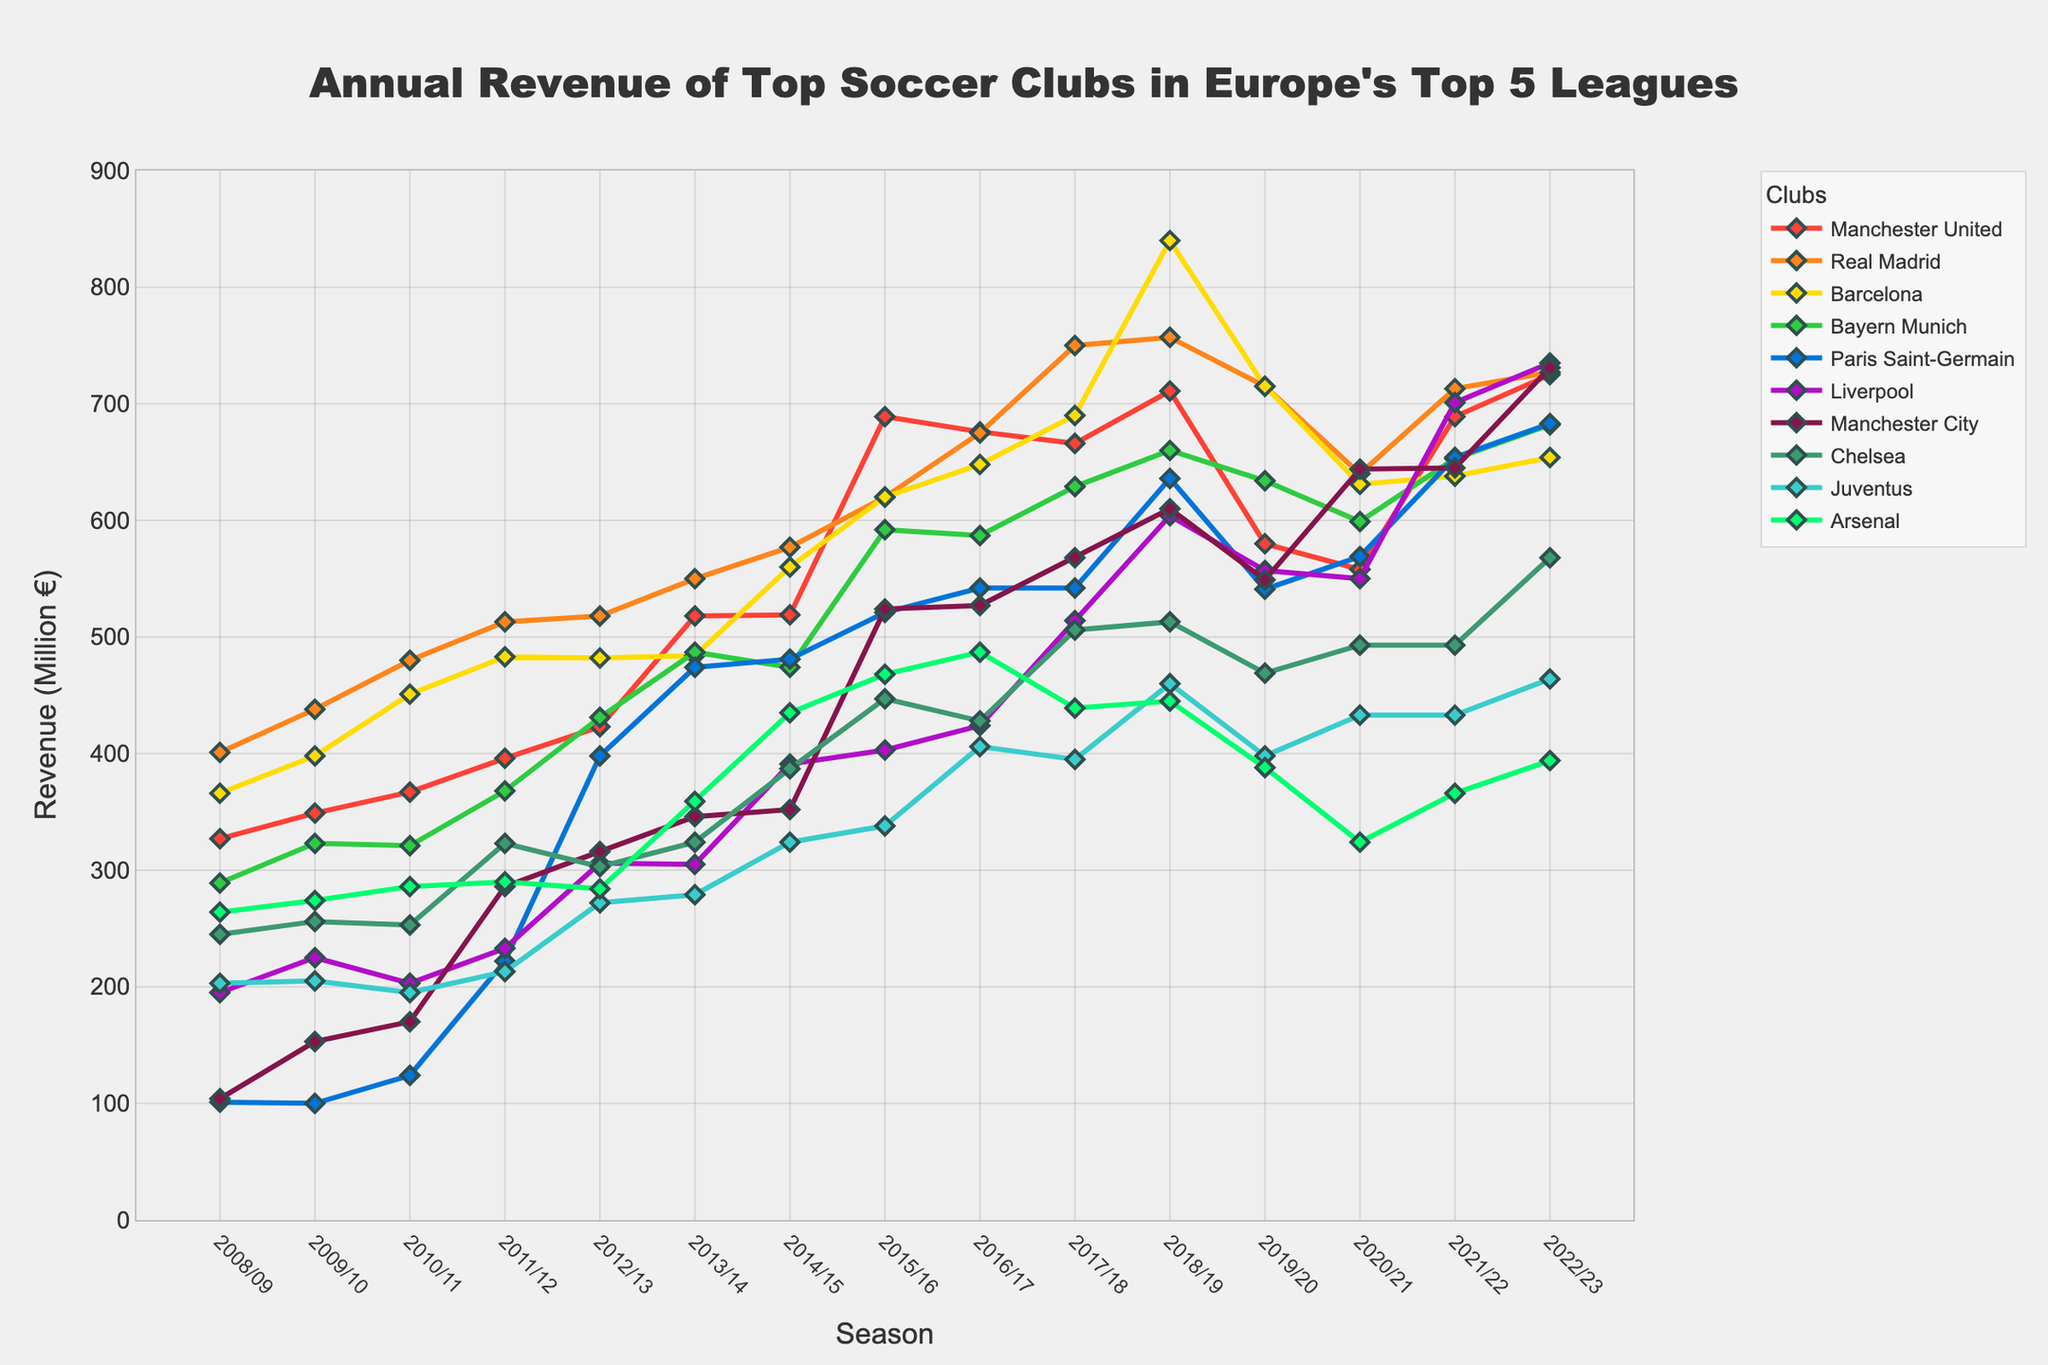Which soccer club had the highest annual revenue in the 2022/23 season? The highest line on the far right of the chart corresponds to the club with the highest revenue in the 2022/23 season. Paris Saint-Germain is at the top.
Answer: Paris Saint-Germain How did the revenue of Manchester United change from the 2008/09 season to the 2022/23 season? Look at the line representing Manchester United (distinguishable by a specific color) from the first to the last data point. The revenue increased from 327 million to 725 million euros.
Answer: Increased Which clubs had a drop in annual revenue between the 2018/19 season and the 2019/20 season? Compare the positions of the lines for each club between 2018/19 and 2019/20. The lines that descend in this period represent a drop. Manchester City, Real Madrid, Barcelona, Bayern Munich, Paris Saint-Germain, Chelsea, Juventus, and Arsenal all show a decrease.
Answer: Manchester City, Real Madrid, Barcelona, Bayern Munich, Paris Saint-Germain, Chelsea, Juventus, Arsenal Which club has shown a consistent increase in revenue over the past 15 seasons? Look for the line that moves consistently upward, without significant drops, across all the seasons. Paris Saint-Germain shows a consistent increase.
Answer: Paris Saint-Germain What is the average annual revenue of Juventus from the 2015/16 season to the 2022/23 season? Sum the revenues of Juventus from 2015/16 to 2022/23 (338 + 406 + 395 + 460 + 398 + 433 + 433 + 464) and divide by the number of seasons (8). Sum = 3327, so the average is 3327/8 = 415.875 million euros.
Answer: 415.875 million euros During the 2019/20 season, which club had the lowest revenue, and what was the amount? Find the lowest point on the graph for the 2019/20 season. Arsenal had the lowest revenue with 388 million euros.
Answer: Arsenal, 388 million euros How much more revenue did Liverpool generate in the 2022/23 season compared to the 2008/09 season? Subtract Liverpool's revenue in 2008/09 from its revenue in 2022/23 (735 - 195). The difference is 540 million euros.
Answer: 540 million euros Between the seasons 2017/18 and 2018/19, which club had the largest increase in revenue? Identify the line with the steepest upward movement between these two seasons. Barcelona shows the steepest rise from 690 to 840 million euros.
Answer: Barcelona What is the overall trend in revenue for Arsenal from the 2008/09 season to the 2022/23 season? Observe the line for Arsenal across all seasons. The trend shows fluctuations but an overall decrease from 264 to 394 million euros.
Answer: Decrease In the 2020/21 season, which clubs had similar revenues? Identify lines that are closely together during the 2020/21 season. Manchester City and Liverpool both had similar revenues around 644 and 550 million euros respectively.
Answer: Manchester City, Liverpool 